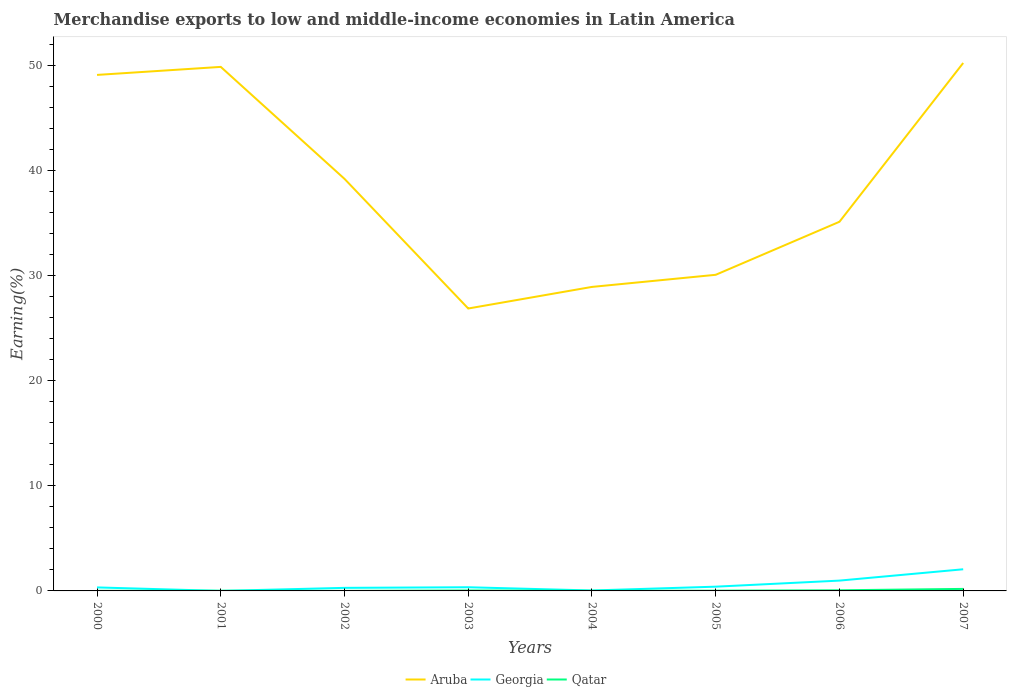How many different coloured lines are there?
Offer a very short reply. 3. Does the line corresponding to Georgia intersect with the line corresponding to Qatar?
Offer a terse response. Yes. Across all years, what is the maximum percentage of amount earned from merchandise exports in Qatar?
Keep it short and to the point. 0.01. In which year was the percentage of amount earned from merchandise exports in Aruba maximum?
Ensure brevity in your answer.  2003. What is the total percentage of amount earned from merchandise exports in Aruba in the graph?
Your response must be concise. 22.23. What is the difference between the highest and the second highest percentage of amount earned from merchandise exports in Georgia?
Ensure brevity in your answer.  2.06. Is the percentage of amount earned from merchandise exports in Aruba strictly greater than the percentage of amount earned from merchandise exports in Qatar over the years?
Your response must be concise. No. How many lines are there?
Provide a short and direct response. 3. How many years are there in the graph?
Ensure brevity in your answer.  8. Are the values on the major ticks of Y-axis written in scientific E-notation?
Provide a succinct answer. No. Does the graph contain any zero values?
Your answer should be compact. No. Does the graph contain grids?
Keep it short and to the point. No. How many legend labels are there?
Provide a succinct answer. 3. How are the legend labels stacked?
Provide a succinct answer. Horizontal. What is the title of the graph?
Your response must be concise. Merchandise exports to low and middle-income economies in Latin America. Does "Kazakhstan" appear as one of the legend labels in the graph?
Your answer should be compact. No. What is the label or title of the Y-axis?
Your answer should be compact. Earning(%). What is the Earning(%) in Aruba in 2000?
Your answer should be compact. 49.1. What is the Earning(%) in Georgia in 2000?
Give a very brief answer. 0.33. What is the Earning(%) of Qatar in 2000?
Offer a terse response. 0.01. What is the Earning(%) of Aruba in 2001?
Make the answer very short. 49.86. What is the Earning(%) in Georgia in 2001?
Make the answer very short. 0. What is the Earning(%) in Qatar in 2001?
Ensure brevity in your answer.  0.01. What is the Earning(%) of Aruba in 2002?
Make the answer very short. 39.21. What is the Earning(%) of Georgia in 2002?
Ensure brevity in your answer.  0.29. What is the Earning(%) in Qatar in 2002?
Keep it short and to the point. 0.01. What is the Earning(%) of Aruba in 2003?
Provide a succinct answer. 26.87. What is the Earning(%) of Georgia in 2003?
Your answer should be compact. 0.35. What is the Earning(%) in Qatar in 2003?
Your answer should be very brief. 0.04. What is the Earning(%) in Aruba in 2004?
Your answer should be compact. 28.93. What is the Earning(%) in Georgia in 2004?
Give a very brief answer. 0.04. What is the Earning(%) in Qatar in 2004?
Give a very brief answer. 0.01. What is the Earning(%) of Aruba in 2005?
Provide a short and direct response. 30.08. What is the Earning(%) in Georgia in 2005?
Ensure brevity in your answer.  0.4. What is the Earning(%) in Qatar in 2005?
Provide a short and direct response. 0.03. What is the Earning(%) in Aruba in 2006?
Ensure brevity in your answer.  35.12. What is the Earning(%) in Georgia in 2006?
Offer a very short reply. 0.98. What is the Earning(%) of Qatar in 2006?
Offer a terse response. 0.06. What is the Earning(%) in Aruba in 2007?
Give a very brief answer. 50.23. What is the Earning(%) of Georgia in 2007?
Offer a terse response. 2.06. What is the Earning(%) in Qatar in 2007?
Offer a very short reply. 0.19. Across all years, what is the maximum Earning(%) of Aruba?
Offer a very short reply. 50.23. Across all years, what is the maximum Earning(%) of Georgia?
Provide a succinct answer. 2.06. Across all years, what is the maximum Earning(%) in Qatar?
Keep it short and to the point. 0.19. Across all years, what is the minimum Earning(%) of Aruba?
Provide a short and direct response. 26.87. Across all years, what is the minimum Earning(%) of Georgia?
Offer a terse response. 0. Across all years, what is the minimum Earning(%) in Qatar?
Your answer should be compact. 0.01. What is the total Earning(%) of Aruba in the graph?
Your answer should be compact. 309.41. What is the total Earning(%) in Georgia in the graph?
Your answer should be compact. 4.46. What is the total Earning(%) in Qatar in the graph?
Provide a succinct answer. 0.36. What is the difference between the Earning(%) in Aruba in 2000 and that in 2001?
Offer a terse response. -0.76. What is the difference between the Earning(%) of Georgia in 2000 and that in 2001?
Give a very brief answer. 0.33. What is the difference between the Earning(%) of Qatar in 2000 and that in 2001?
Provide a short and direct response. -0. What is the difference between the Earning(%) in Aruba in 2000 and that in 2002?
Your answer should be very brief. 9.89. What is the difference between the Earning(%) in Georgia in 2000 and that in 2002?
Give a very brief answer. 0.04. What is the difference between the Earning(%) in Qatar in 2000 and that in 2002?
Make the answer very short. 0.01. What is the difference between the Earning(%) in Aruba in 2000 and that in 2003?
Offer a terse response. 22.23. What is the difference between the Earning(%) in Georgia in 2000 and that in 2003?
Offer a terse response. -0.02. What is the difference between the Earning(%) in Qatar in 2000 and that in 2003?
Your response must be concise. -0.03. What is the difference between the Earning(%) in Aruba in 2000 and that in 2004?
Your answer should be compact. 20.17. What is the difference between the Earning(%) of Georgia in 2000 and that in 2004?
Ensure brevity in your answer.  0.29. What is the difference between the Earning(%) of Qatar in 2000 and that in 2004?
Provide a succinct answer. 0. What is the difference between the Earning(%) of Aruba in 2000 and that in 2005?
Ensure brevity in your answer.  19.02. What is the difference between the Earning(%) in Georgia in 2000 and that in 2005?
Your response must be concise. -0.07. What is the difference between the Earning(%) in Qatar in 2000 and that in 2005?
Offer a very short reply. -0.01. What is the difference between the Earning(%) in Aruba in 2000 and that in 2006?
Your answer should be very brief. 13.97. What is the difference between the Earning(%) in Georgia in 2000 and that in 2006?
Your answer should be very brief. -0.65. What is the difference between the Earning(%) of Qatar in 2000 and that in 2006?
Keep it short and to the point. -0.05. What is the difference between the Earning(%) in Aruba in 2000 and that in 2007?
Your answer should be compact. -1.14. What is the difference between the Earning(%) in Georgia in 2000 and that in 2007?
Your response must be concise. -1.73. What is the difference between the Earning(%) of Qatar in 2000 and that in 2007?
Your response must be concise. -0.18. What is the difference between the Earning(%) in Aruba in 2001 and that in 2002?
Offer a terse response. 10.65. What is the difference between the Earning(%) in Georgia in 2001 and that in 2002?
Make the answer very short. -0.29. What is the difference between the Earning(%) of Qatar in 2001 and that in 2002?
Provide a succinct answer. 0.01. What is the difference between the Earning(%) of Aruba in 2001 and that in 2003?
Ensure brevity in your answer.  22.99. What is the difference between the Earning(%) of Georgia in 2001 and that in 2003?
Ensure brevity in your answer.  -0.35. What is the difference between the Earning(%) in Qatar in 2001 and that in 2003?
Your response must be concise. -0.03. What is the difference between the Earning(%) of Aruba in 2001 and that in 2004?
Your answer should be very brief. 20.94. What is the difference between the Earning(%) in Georgia in 2001 and that in 2004?
Provide a short and direct response. -0.04. What is the difference between the Earning(%) of Qatar in 2001 and that in 2004?
Keep it short and to the point. 0. What is the difference between the Earning(%) in Aruba in 2001 and that in 2005?
Provide a succinct answer. 19.78. What is the difference between the Earning(%) in Georgia in 2001 and that in 2005?
Offer a terse response. -0.4. What is the difference between the Earning(%) in Qatar in 2001 and that in 2005?
Ensure brevity in your answer.  -0.01. What is the difference between the Earning(%) in Aruba in 2001 and that in 2006?
Give a very brief answer. 14.74. What is the difference between the Earning(%) of Georgia in 2001 and that in 2006?
Offer a very short reply. -0.98. What is the difference between the Earning(%) in Qatar in 2001 and that in 2006?
Ensure brevity in your answer.  -0.05. What is the difference between the Earning(%) in Aruba in 2001 and that in 2007?
Keep it short and to the point. -0.37. What is the difference between the Earning(%) of Georgia in 2001 and that in 2007?
Your answer should be very brief. -2.06. What is the difference between the Earning(%) in Qatar in 2001 and that in 2007?
Make the answer very short. -0.18. What is the difference between the Earning(%) in Aruba in 2002 and that in 2003?
Give a very brief answer. 12.34. What is the difference between the Earning(%) of Georgia in 2002 and that in 2003?
Provide a succinct answer. -0.06. What is the difference between the Earning(%) in Qatar in 2002 and that in 2003?
Make the answer very short. -0.04. What is the difference between the Earning(%) in Aruba in 2002 and that in 2004?
Your answer should be compact. 10.28. What is the difference between the Earning(%) in Georgia in 2002 and that in 2004?
Provide a succinct answer. 0.25. What is the difference between the Earning(%) in Qatar in 2002 and that in 2004?
Your response must be concise. -0. What is the difference between the Earning(%) of Aruba in 2002 and that in 2005?
Your response must be concise. 9.13. What is the difference between the Earning(%) in Georgia in 2002 and that in 2005?
Your answer should be compact. -0.11. What is the difference between the Earning(%) of Qatar in 2002 and that in 2005?
Ensure brevity in your answer.  -0.02. What is the difference between the Earning(%) in Aruba in 2002 and that in 2006?
Offer a terse response. 4.08. What is the difference between the Earning(%) of Georgia in 2002 and that in 2006?
Offer a terse response. -0.69. What is the difference between the Earning(%) in Qatar in 2002 and that in 2006?
Provide a succinct answer. -0.06. What is the difference between the Earning(%) of Aruba in 2002 and that in 2007?
Offer a terse response. -11.03. What is the difference between the Earning(%) in Georgia in 2002 and that in 2007?
Make the answer very short. -1.77. What is the difference between the Earning(%) of Qatar in 2002 and that in 2007?
Your answer should be very brief. -0.19. What is the difference between the Earning(%) of Aruba in 2003 and that in 2004?
Offer a very short reply. -2.05. What is the difference between the Earning(%) of Georgia in 2003 and that in 2004?
Offer a very short reply. 0.31. What is the difference between the Earning(%) in Qatar in 2003 and that in 2004?
Make the answer very short. 0.03. What is the difference between the Earning(%) of Aruba in 2003 and that in 2005?
Provide a short and direct response. -3.21. What is the difference between the Earning(%) in Georgia in 2003 and that in 2005?
Give a very brief answer. -0.05. What is the difference between the Earning(%) in Qatar in 2003 and that in 2005?
Give a very brief answer. 0.02. What is the difference between the Earning(%) in Aruba in 2003 and that in 2006?
Your answer should be very brief. -8.25. What is the difference between the Earning(%) of Georgia in 2003 and that in 2006?
Ensure brevity in your answer.  -0.63. What is the difference between the Earning(%) in Qatar in 2003 and that in 2006?
Provide a short and direct response. -0.02. What is the difference between the Earning(%) of Aruba in 2003 and that in 2007?
Your answer should be very brief. -23.36. What is the difference between the Earning(%) in Georgia in 2003 and that in 2007?
Offer a very short reply. -1.71. What is the difference between the Earning(%) of Qatar in 2003 and that in 2007?
Provide a short and direct response. -0.15. What is the difference between the Earning(%) of Aruba in 2004 and that in 2005?
Your answer should be very brief. -1.15. What is the difference between the Earning(%) of Georgia in 2004 and that in 2005?
Offer a very short reply. -0.36. What is the difference between the Earning(%) in Qatar in 2004 and that in 2005?
Provide a succinct answer. -0.02. What is the difference between the Earning(%) in Aruba in 2004 and that in 2006?
Offer a very short reply. -6.2. What is the difference between the Earning(%) of Georgia in 2004 and that in 2006?
Provide a succinct answer. -0.94. What is the difference between the Earning(%) in Qatar in 2004 and that in 2006?
Make the answer very short. -0.05. What is the difference between the Earning(%) of Aruba in 2004 and that in 2007?
Offer a very short reply. -21.31. What is the difference between the Earning(%) of Georgia in 2004 and that in 2007?
Offer a terse response. -2.02. What is the difference between the Earning(%) of Qatar in 2004 and that in 2007?
Your response must be concise. -0.18. What is the difference between the Earning(%) in Aruba in 2005 and that in 2006?
Provide a short and direct response. -5.05. What is the difference between the Earning(%) in Georgia in 2005 and that in 2006?
Provide a succinct answer. -0.58. What is the difference between the Earning(%) in Qatar in 2005 and that in 2006?
Give a very brief answer. -0.04. What is the difference between the Earning(%) of Aruba in 2005 and that in 2007?
Provide a succinct answer. -20.16. What is the difference between the Earning(%) in Georgia in 2005 and that in 2007?
Offer a very short reply. -1.66. What is the difference between the Earning(%) in Qatar in 2005 and that in 2007?
Ensure brevity in your answer.  -0.17. What is the difference between the Earning(%) in Aruba in 2006 and that in 2007?
Give a very brief answer. -15.11. What is the difference between the Earning(%) of Georgia in 2006 and that in 2007?
Provide a succinct answer. -1.08. What is the difference between the Earning(%) in Qatar in 2006 and that in 2007?
Provide a short and direct response. -0.13. What is the difference between the Earning(%) of Aruba in 2000 and the Earning(%) of Georgia in 2001?
Keep it short and to the point. 49.1. What is the difference between the Earning(%) in Aruba in 2000 and the Earning(%) in Qatar in 2001?
Provide a short and direct response. 49.08. What is the difference between the Earning(%) of Georgia in 2000 and the Earning(%) of Qatar in 2001?
Offer a very short reply. 0.32. What is the difference between the Earning(%) of Aruba in 2000 and the Earning(%) of Georgia in 2002?
Your answer should be very brief. 48.81. What is the difference between the Earning(%) in Aruba in 2000 and the Earning(%) in Qatar in 2002?
Keep it short and to the point. 49.09. What is the difference between the Earning(%) of Georgia in 2000 and the Earning(%) of Qatar in 2002?
Provide a short and direct response. 0.33. What is the difference between the Earning(%) in Aruba in 2000 and the Earning(%) in Georgia in 2003?
Offer a very short reply. 48.75. What is the difference between the Earning(%) in Aruba in 2000 and the Earning(%) in Qatar in 2003?
Provide a succinct answer. 49.05. What is the difference between the Earning(%) in Georgia in 2000 and the Earning(%) in Qatar in 2003?
Make the answer very short. 0.29. What is the difference between the Earning(%) in Aruba in 2000 and the Earning(%) in Georgia in 2004?
Your answer should be compact. 49.06. What is the difference between the Earning(%) in Aruba in 2000 and the Earning(%) in Qatar in 2004?
Provide a succinct answer. 49.09. What is the difference between the Earning(%) of Georgia in 2000 and the Earning(%) of Qatar in 2004?
Provide a succinct answer. 0.32. What is the difference between the Earning(%) in Aruba in 2000 and the Earning(%) in Georgia in 2005?
Keep it short and to the point. 48.69. What is the difference between the Earning(%) in Aruba in 2000 and the Earning(%) in Qatar in 2005?
Give a very brief answer. 49.07. What is the difference between the Earning(%) in Georgia in 2000 and the Earning(%) in Qatar in 2005?
Provide a succinct answer. 0.31. What is the difference between the Earning(%) in Aruba in 2000 and the Earning(%) in Georgia in 2006?
Offer a terse response. 48.12. What is the difference between the Earning(%) in Aruba in 2000 and the Earning(%) in Qatar in 2006?
Your answer should be very brief. 49.04. What is the difference between the Earning(%) in Georgia in 2000 and the Earning(%) in Qatar in 2006?
Provide a short and direct response. 0.27. What is the difference between the Earning(%) of Aruba in 2000 and the Earning(%) of Georgia in 2007?
Give a very brief answer. 47.04. What is the difference between the Earning(%) in Aruba in 2000 and the Earning(%) in Qatar in 2007?
Your answer should be compact. 48.91. What is the difference between the Earning(%) in Georgia in 2000 and the Earning(%) in Qatar in 2007?
Provide a succinct answer. 0.14. What is the difference between the Earning(%) in Aruba in 2001 and the Earning(%) in Georgia in 2002?
Your answer should be very brief. 49.57. What is the difference between the Earning(%) of Aruba in 2001 and the Earning(%) of Qatar in 2002?
Keep it short and to the point. 49.86. What is the difference between the Earning(%) in Georgia in 2001 and the Earning(%) in Qatar in 2002?
Provide a short and direct response. -0. What is the difference between the Earning(%) of Aruba in 2001 and the Earning(%) of Georgia in 2003?
Your response must be concise. 49.51. What is the difference between the Earning(%) in Aruba in 2001 and the Earning(%) in Qatar in 2003?
Your answer should be compact. 49.82. What is the difference between the Earning(%) of Georgia in 2001 and the Earning(%) of Qatar in 2003?
Offer a terse response. -0.04. What is the difference between the Earning(%) of Aruba in 2001 and the Earning(%) of Georgia in 2004?
Keep it short and to the point. 49.82. What is the difference between the Earning(%) in Aruba in 2001 and the Earning(%) in Qatar in 2004?
Your answer should be compact. 49.85. What is the difference between the Earning(%) in Georgia in 2001 and the Earning(%) in Qatar in 2004?
Your answer should be very brief. -0.01. What is the difference between the Earning(%) of Aruba in 2001 and the Earning(%) of Georgia in 2005?
Offer a very short reply. 49.46. What is the difference between the Earning(%) of Aruba in 2001 and the Earning(%) of Qatar in 2005?
Your response must be concise. 49.84. What is the difference between the Earning(%) of Georgia in 2001 and the Earning(%) of Qatar in 2005?
Ensure brevity in your answer.  -0.02. What is the difference between the Earning(%) of Aruba in 2001 and the Earning(%) of Georgia in 2006?
Give a very brief answer. 48.88. What is the difference between the Earning(%) of Aruba in 2001 and the Earning(%) of Qatar in 2006?
Keep it short and to the point. 49.8. What is the difference between the Earning(%) in Georgia in 2001 and the Earning(%) in Qatar in 2006?
Keep it short and to the point. -0.06. What is the difference between the Earning(%) of Aruba in 2001 and the Earning(%) of Georgia in 2007?
Provide a succinct answer. 47.8. What is the difference between the Earning(%) in Aruba in 2001 and the Earning(%) in Qatar in 2007?
Give a very brief answer. 49.67. What is the difference between the Earning(%) of Georgia in 2001 and the Earning(%) of Qatar in 2007?
Offer a terse response. -0.19. What is the difference between the Earning(%) of Aruba in 2002 and the Earning(%) of Georgia in 2003?
Keep it short and to the point. 38.86. What is the difference between the Earning(%) of Aruba in 2002 and the Earning(%) of Qatar in 2003?
Make the answer very short. 39.16. What is the difference between the Earning(%) of Georgia in 2002 and the Earning(%) of Qatar in 2003?
Offer a terse response. 0.25. What is the difference between the Earning(%) in Aruba in 2002 and the Earning(%) in Georgia in 2004?
Provide a short and direct response. 39.17. What is the difference between the Earning(%) in Aruba in 2002 and the Earning(%) in Qatar in 2004?
Your response must be concise. 39.2. What is the difference between the Earning(%) of Georgia in 2002 and the Earning(%) of Qatar in 2004?
Your answer should be compact. 0.28. What is the difference between the Earning(%) in Aruba in 2002 and the Earning(%) in Georgia in 2005?
Your answer should be compact. 38.8. What is the difference between the Earning(%) in Aruba in 2002 and the Earning(%) in Qatar in 2005?
Offer a terse response. 39.18. What is the difference between the Earning(%) of Georgia in 2002 and the Earning(%) of Qatar in 2005?
Your response must be concise. 0.27. What is the difference between the Earning(%) of Aruba in 2002 and the Earning(%) of Georgia in 2006?
Give a very brief answer. 38.23. What is the difference between the Earning(%) in Aruba in 2002 and the Earning(%) in Qatar in 2006?
Make the answer very short. 39.15. What is the difference between the Earning(%) of Georgia in 2002 and the Earning(%) of Qatar in 2006?
Keep it short and to the point. 0.23. What is the difference between the Earning(%) in Aruba in 2002 and the Earning(%) in Georgia in 2007?
Your answer should be compact. 37.15. What is the difference between the Earning(%) in Aruba in 2002 and the Earning(%) in Qatar in 2007?
Provide a short and direct response. 39.02. What is the difference between the Earning(%) in Georgia in 2002 and the Earning(%) in Qatar in 2007?
Provide a succinct answer. 0.1. What is the difference between the Earning(%) in Aruba in 2003 and the Earning(%) in Georgia in 2004?
Provide a succinct answer. 26.83. What is the difference between the Earning(%) in Aruba in 2003 and the Earning(%) in Qatar in 2004?
Your response must be concise. 26.86. What is the difference between the Earning(%) in Georgia in 2003 and the Earning(%) in Qatar in 2004?
Provide a succinct answer. 0.34. What is the difference between the Earning(%) in Aruba in 2003 and the Earning(%) in Georgia in 2005?
Your response must be concise. 26.47. What is the difference between the Earning(%) of Aruba in 2003 and the Earning(%) of Qatar in 2005?
Your answer should be very brief. 26.85. What is the difference between the Earning(%) in Georgia in 2003 and the Earning(%) in Qatar in 2005?
Your response must be concise. 0.32. What is the difference between the Earning(%) in Aruba in 2003 and the Earning(%) in Georgia in 2006?
Make the answer very short. 25.89. What is the difference between the Earning(%) of Aruba in 2003 and the Earning(%) of Qatar in 2006?
Keep it short and to the point. 26.81. What is the difference between the Earning(%) in Georgia in 2003 and the Earning(%) in Qatar in 2006?
Offer a very short reply. 0.29. What is the difference between the Earning(%) in Aruba in 2003 and the Earning(%) in Georgia in 2007?
Ensure brevity in your answer.  24.81. What is the difference between the Earning(%) in Aruba in 2003 and the Earning(%) in Qatar in 2007?
Provide a succinct answer. 26.68. What is the difference between the Earning(%) in Georgia in 2003 and the Earning(%) in Qatar in 2007?
Your response must be concise. 0.16. What is the difference between the Earning(%) of Aruba in 2004 and the Earning(%) of Georgia in 2005?
Give a very brief answer. 28.52. What is the difference between the Earning(%) of Aruba in 2004 and the Earning(%) of Qatar in 2005?
Offer a very short reply. 28.9. What is the difference between the Earning(%) in Georgia in 2004 and the Earning(%) in Qatar in 2005?
Provide a succinct answer. 0.02. What is the difference between the Earning(%) of Aruba in 2004 and the Earning(%) of Georgia in 2006?
Give a very brief answer. 27.94. What is the difference between the Earning(%) of Aruba in 2004 and the Earning(%) of Qatar in 2006?
Your response must be concise. 28.87. What is the difference between the Earning(%) of Georgia in 2004 and the Earning(%) of Qatar in 2006?
Offer a terse response. -0.02. What is the difference between the Earning(%) in Aruba in 2004 and the Earning(%) in Georgia in 2007?
Your response must be concise. 26.87. What is the difference between the Earning(%) in Aruba in 2004 and the Earning(%) in Qatar in 2007?
Offer a very short reply. 28.73. What is the difference between the Earning(%) of Georgia in 2004 and the Earning(%) of Qatar in 2007?
Keep it short and to the point. -0.15. What is the difference between the Earning(%) in Aruba in 2005 and the Earning(%) in Georgia in 2006?
Offer a terse response. 29.1. What is the difference between the Earning(%) in Aruba in 2005 and the Earning(%) in Qatar in 2006?
Make the answer very short. 30.02. What is the difference between the Earning(%) in Georgia in 2005 and the Earning(%) in Qatar in 2006?
Provide a short and direct response. 0.34. What is the difference between the Earning(%) of Aruba in 2005 and the Earning(%) of Georgia in 2007?
Give a very brief answer. 28.02. What is the difference between the Earning(%) of Aruba in 2005 and the Earning(%) of Qatar in 2007?
Make the answer very short. 29.89. What is the difference between the Earning(%) in Georgia in 2005 and the Earning(%) in Qatar in 2007?
Keep it short and to the point. 0.21. What is the difference between the Earning(%) in Aruba in 2006 and the Earning(%) in Georgia in 2007?
Give a very brief answer. 33.06. What is the difference between the Earning(%) in Aruba in 2006 and the Earning(%) in Qatar in 2007?
Offer a very short reply. 34.93. What is the difference between the Earning(%) in Georgia in 2006 and the Earning(%) in Qatar in 2007?
Make the answer very short. 0.79. What is the average Earning(%) in Aruba per year?
Provide a short and direct response. 38.68. What is the average Earning(%) of Georgia per year?
Make the answer very short. 0.56. What is the average Earning(%) of Qatar per year?
Make the answer very short. 0.05. In the year 2000, what is the difference between the Earning(%) in Aruba and Earning(%) in Georgia?
Provide a short and direct response. 48.77. In the year 2000, what is the difference between the Earning(%) in Aruba and Earning(%) in Qatar?
Give a very brief answer. 49.09. In the year 2000, what is the difference between the Earning(%) in Georgia and Earning(%) in Qatar?
Provide a short and direct response. 0.32. In the year 2001, what is the difference between the Earning(%) in Aruba and Earning(%) in Georgia?
Provide a succinct answer. 49.86. In the year 2001, what is the difference between the Earning(%) of Aruba and Earning(%) of Qatar?
Your answer should be very brief. 49.85. In the year 2001, what is the difference between the Earning(%) in Georgia and Earning(%) in Qatar?
Ensure brevity in your answer.  -0.01. In the year 2002, what is the difference between the Earning(%) of Aruba and Earning(%) of Georgia?
Ensure brevity in your answer.  38.92. In the year 2002, what is the difference between the Earning(%) of Aruba and Earning(%) of Qatar?
Offer a very short reply. 39.2. In the year 2002, what is the difference between the Earning(%) in Georgia and Earning(%) in Qatar?
Provide a short and direct response. 0.29. In the year 2003, what is the difference between the Earning(%) of Aruba and Earning(%) of Georgia?
Make the answer very short. 26.52. In the year 2003, what is the difference between the Earning(%) in Aruba and Earning(%) in Qatar?
Provide a short and direct response. 26.83. In the year 2003, what is the difference between the Earning(%) of Georgia and Earning(%) of Qatar?
Make the answer very short. 0.31. In the year 2004, what is the difference between the Earning(%) in Aruba and Earning(%) in Georgia?
Provide a short and direct response. 28.89. In the year 2004, what is the difference between the Earning(%) in Aruba and Earning(%) in Qatar?
Offer a terse response. 28.92. In the year 2004, what is the difference between the Earning(%) in Georgia and Earning(%) in Qatar?
Your response must be concise. 0.03. In the year 2005, what is the difference between the Earning(%) in Aruba and Earning(%) in Georgia?
Offer a very short reply. 29.67. In the year 2005, what is the difference between the Earning(%) of Aruba and Earning(%) of Qatar?
Your answer should be very brief. 30.05. In the year 2005, what is the difference between the Earning(%) of Georgia and Earning(%) of Qatar?
Your answer should be very brief. 0.38. In the year 2006, what is the difference between the Earning(%) of Aruba and Earning(%) of Georgia?
Provide a succinct answer. 34.14. In the year 2006, what is the difference between the Earning(%) in Aruba and Earning(%) in Qatar?
Ensure brevity in your answer.  35.06. In the year 2006, what is the difference between the Earning(%) of Georgia and Earning(%) of Qatar?
Provide a short and direct response. 0.92. In the year 2007, what is the difference between the Earning(%) in Aruba and Earning(%) in Georgia?
Your response must be concise. 48.17. In the year 2007, what is the difference between the Earning(%) of Aruba and Earning(%) of Qatar?
Your response must be concise. 50.04. In the year 2007, what is the difference between the Earning(%) of Georgia and Earning(%) of Qatar?
Your response must be concise. 1.87. What is the ratio of the Earning(%) in Aruba in 2000 to that in 2001?
Give a very brief answer. 0.98. What is the ratio of the Earning(%) of Georgia in 2000 to that in 2001?
Ensure brevity in your answer.  242.79. What is the ratio of the Earning(%) of Qatar in 2000 to that in 2001?
Offer a terse response. 0.83. What is the ratio of the Earning(%) in Aruba in 2000 to that in 2002?
Your response must be concise. 1.25. What is the ratio of the Earning(%) in Georgia in 2000 to that in 2002?
Ensure brevity in your answer.  1.14. What is the ratio of the Earning(%) of Qatar in 2000 to that in 2002?
Offer a terse response. 2.36. What is the ratio of the Earning(%) in Aruba in 2000 to that in 2003?
Your answer should be very brief. 1.83. What is the ratio of the Earning(%) in Georgia in 2000 to that in 2003?
Your answer should be compact. 0.95. What is the ratio of the Earning(%) of Qatar in 2000 to that in 2003?
Make the answer very short. 0.28. What is the ratio of the Earning(%) in Aruba in 2000 to that in 2004?
Offer a terse response. 1.7. What is the ratio of the Earning(%) in Georgia in 2000 to that in 2004?
Your answer should be compact. 8.08. What is the ratio of the Earning(%) in Qatar in 2000 to that in 2004?
Your response must be concise. 1.23. What is the ratio of the Earning(%) in Aruba in 2000 to that in 2005?
Offer a terse response. 1.63. What is the ratio of the Earning(%) of Georgia in 2000 to that in 2005?
Offer a very short reply. 0.82. What is the ratio of the Earning(%) in Qatar in 2000 to that in 2005?
Offer a very short reply. 0.48. What is the ratio of the Earning(%) of Aruba in 2000 to that in 2006?
Offer a very short reply. 1.4. What is the ratio of the Earning(%) of Georgia in 2000 to that in 2006?
Make the answer very short. 0.34. What is the ratio of the Earning(%) in Qatar in 2000 to that in 2006?
Your answer should be compact. 0.2. What is the ratio of the Earning(%) in Aruba in 2000 to that in 2007?
Your answer should be very brief. 0.98. What is the ratio of the Earning(%) of Georgia in 2000 to that in 2007?
Offer a terse response. 0.16. What is the ratio of the Earning(%) of Qatar in 2000 to that in 2007?
Keep it short and to the point. 0.06. What is the ratio of the Earning(%) in Aruba in 2001 to that in 2002?
Your response must be concise. 1.27. What is the ratio of the Earning(%) in Georgia in 2001 to that in 2002?
Ensure brevity in your answer.  0. What is the ratio of the Earning(%) of Qatar in 2001 to that in 2002?
Your response must be concise. 2.84. What is the ratio of the Earning(%) of Aruba in 2001 to that in 2003?
Your answer should be compact. 1.86. What is the ratio of the Earning(%) in Georgia in 2001 to that in 2003?
Offer a terse response. 0. What is the ratio of the Earning(%) of Qatar in 2001 to that in 2003?
Your answer should be very brief. 0.34. What is the ratio of the Earning(%) in Aruba in 2001 to that in 2004?
Your answer should be very brief. 1.72. What is the ratio of the Earning(%) of Georgia in 2001 to that in 2004?
Ensure brevity in your answer.  0.03. What is the ratio of the Earning(%) of Qatar in 2001 to that in 2004?
Offer a terse response. 1.48. What is the ratio of the Earning(%) of Aruba in 2001 to that in 2005?
Ensure brevity in your answer.  1.66. What is the ratio of the Earning(%) in Georgia in 2001 to that in 2005?
Provide a short and direct response. 0. What is the ratio of the Earning(%) in Qatar in 2001 to that in 2005?
Your answer should be compact. 0.58. What is the ratio of the Earning(%) in Aruba in 2001 to that in 2006?
Keep it short and to the point. 1.42. What is the ratio of the Earning(%) in Georgia in 2001 to that in 2006?
Offer a very short reply. 0. What is the ratio of the Earning(%) in Qatar in 2001 to that in 2006?
Provide a short and direct response. 0.24. What is the ratio of the Earning(%) in Aruba in 2001 to that in 2007?
Provide a short and direct response. 0.99. What is the ratio of the Earning(%) of Georgia in 2001 to that in 2007?
Your response must be concise. 0. What is the ratio of the Earning(%) in Qatar in 2001 to that in 2007?
Your answer should be compact. 0.08. What is the ratio of the Earning(%) in Aruba in 2002 to that in 2003?
Your answer should be compact. 1.46. What is the ratio of the Earning(%) in Georgia in 2002 to that in 2003?
Offer a terse response. 0.83. What is the ratio of the Earning(%) in Qatar in 2002 to that in 2003?
Make the answer very short. 0.12. What is the ratio of the Earning(%) of Aruba in 2002 to that in 2004?
Offer a very short reply. 1.36. What is the ratio of the Earning(%) of Georgia in 2002 to that in 2004?
Your answer should be compact. 7.07. What is the ratio of the Earning(%) in Qatar in 2002 to that in 2004?
Ensure brevity in your answer.  0.52. What is the ratio of the Earning(%) of Aruba in 2002 to that in 2005?
Ensure brevity in your answer.  1.3. What is the ratio of the Earning(%) of Georgia in 2002 to that in 2005?
Give a very brief answer. 0.72. What is the ratio of the Earning(%) in Qatar in 2002 to that in 2005?
Make the answer very short. 0.2. What is the ratio of the Earning(%) of Aruba in 2002 to that in 2006?
Your answer should be very brief. 1.12. What is the ratio of the Earning(%) in Georgia in 2002 to that in 2006?
Keep it short and to the point. 0.3. What is the ratio of the Earning(%) in Qatar in 2002 to that in 2006?
Keep it short and to the point. 0.09. What is the ratio of the Earning(%) of Aruba in 2002 to that in 2007?
Give a very brief answer. 0.78. What is the ratio of the Earning(%) of Georgia in 2002 to that in 2007?
Offer a terse response. 0.14. What is the ratio of the Earning(%) of Qatar in 2002 to that in 2007?
Make the answer very short. 0.03. What is the ratio of the Earning(%) of Aruba in 2003 to that in 2004?
Keep it short and to the point. 0.93. What is the ratio of the Earning(%) in Georgia in 2003 to that in 2004?
Keep it short and to the point. 8.49. What is the ratio of the Earning(%) of Qatar in 2003 to that in 2004?
Keep it short and to the point. 4.4. What is the ratio of the Earning(%) in Aruba in 2003 to that in 2005?
Make the answer very short. 0.89. What is the ratio of the Earning(%) of Georgia in 2003 to that in 2005?
Offer a terse response. 0.87. What is the ratio of the Earning(%) in Qatar in 2003 to that in 2005?
Ensure brevity in your answer.  1.73. What is the ratio of the Earning(%) of Aruba in 2003 to that in 2006?
Provide a short and direct response. 0.77. What is the ratio of the Earning(%) in Georgia in 2003 to that in 2006?
Provide a short and direct response. 0.36. What is the ratio of the Earning(%) of Qatar in 2003 to that in 2006?
Your answer should be very brief. 0.73. What is the ratio of the Earning(%) in Aruba in 2003 to that in 2007?
Your answer should be very brief. 0.53. What is the ratio of the Earning(%) in Georgia in 2003 to that in 2007?
Your response must be concise. 0.17. What is the ratio of the Earning(%) of Qatar in 2003 to that in 2007?
Provide a succinct answer. 0.23. What is the ratio of the Earning(%) in Aruba in 2004 to that in 2005?
Offer a very short reply. 0.96. What is the ratio of the Earning(%) in Georgia in 2004 to that in 2005?
Offer a very short reply. 0.1. What is the ratio of the Earning(%) of Qatar in 2004 to that in 2005?
Keep it short and to the point. 0.39. What is the ratio of the Earning(%) in Aruba in 2004 to that in 2006?
Your response must be concise. 0.82. What is the ratio of the Earning(%) of Georgia in 2004 to that in 2006?
Make the answer very short. 0.04. What is the ratio of the Earning(%) of Qatar in 2004 to that in 2006?
Ensure brevity in your answer.  0.17. What is the ratio of the Earning(%) of Aruba in 2004 to that in 2007?
Provide a succinct answer. 0.58. What is the ratio of the Earning(%) in Qatar in 2004 to that in 2007?
Give a very brief answer. 0.05. What is the ratio of the Earning(%) of Aruba in 2005 to that in 2006?
Provide a succinct answer. 0.86. What is the ratio of the Earning(%) of Georgia in 2005 to that in 2006?
Give a very brief answer. 0.41. What is the ratio of the Earning(%) of Qatar in 2005 to that in 2006?
Give a very brief answer. 0.42. What is the ratio of the Earning(%) in Aruba in 2005 to that in 2007?
Provide a succinct answer. 0.6. What is the ratio of the Earning(%) of Georgia in 2005 to that in 2007?
Your answer should be very brief. 0.2. What is the ratio of the Earning(%) in Qatar in 2005 to that in 2007?
Ensure brevity in your answer.  0.13. What is the ratio of the Earning(%) of Aruba in 2006 to that in 2007?
Keep it short and to the point. 0.7. What is the ratio of the Earning(%) of Georgia in 2006 to that in 2007?
Give a very brief answer. 0.48. What is the ratio of the Earning(%) in Qatar in 2006 to that in 2007?
Give a very brief answer. 0.32. What is the difference between the highest and the second highest Earning(%) of Aruba?
Your response must be concise. 0.37. What is the difference between the highest and the second highest Earning(%) in Georgia?
Offer a terse response. 1.08. What is the difference between the highest and the second highest Earning(%) of Qatar?
Offer a very short reply. 0.13. What is the difference between the highest and the lowest Earning(%) of Aruba?
Offer a terse response. 23.36. What is the difference between the highest and the lowest Earning(%) in Georgia?
Ensure brevity in your answer.  2.06. What is the difference between the highest and the lowest Earning(%) in Qatar?
Ensure brevity in your answer.  0.19. 